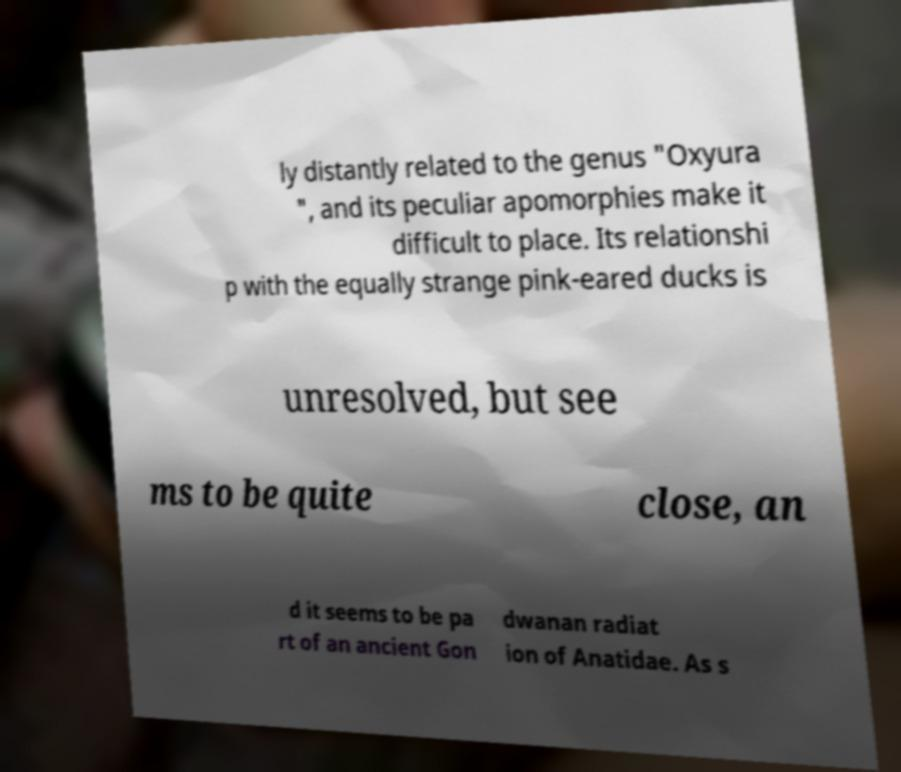Could you extract and type out the text from this image? ly distantly related to the genus "Oxyura ", and its peculiar apomorphies make it difficult to place. Its relationshi p with the equally strange pink-eared ducks is unresolved, but see ms to be quite close, an d it seems to be pa rt of an ancient Gon dwanan radiat ion of Anatidae. As s 